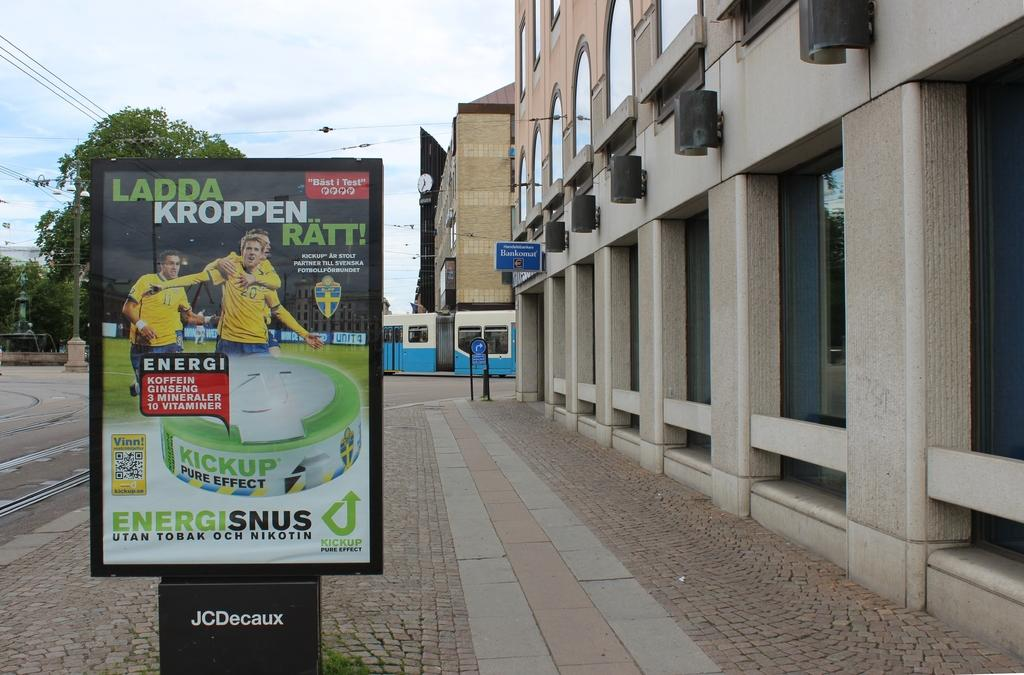<image>
Give a short and clear explanation of the subsequent image. A sign with Energisnus on the bottom is on the sidewalk next to a building. 